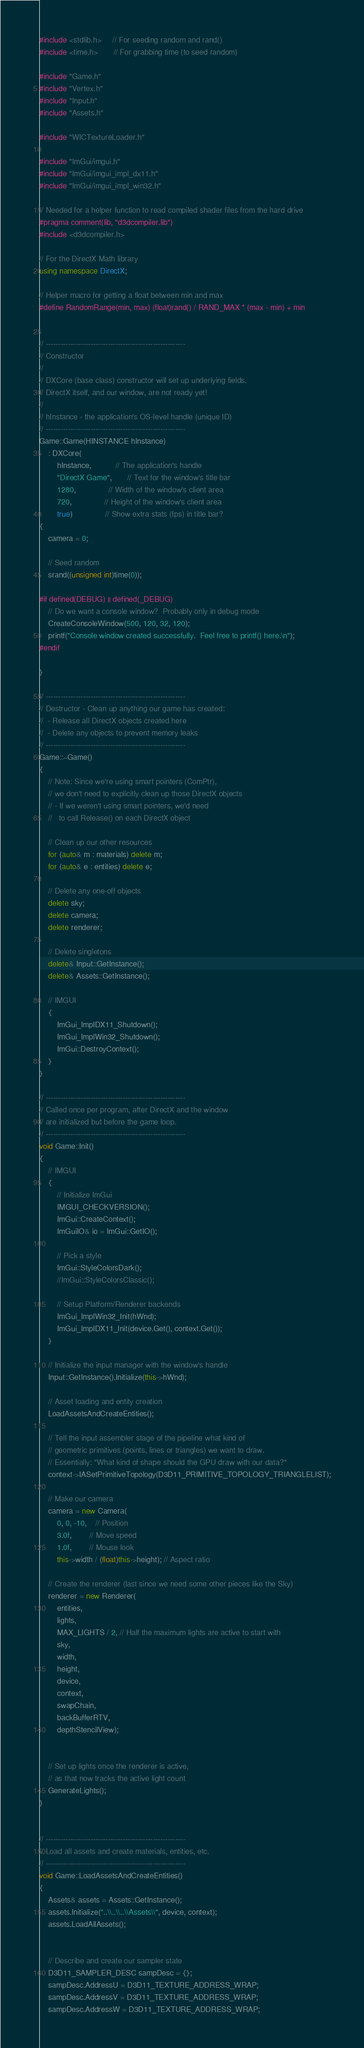Convert code to text. <code><loc_0><loc_0><loc_500><loc_500><_C++_>
#include <stdlib.h>     // For seeding random and rand()
#include <time.h>       // For grabbing time (to seed random)

#include "Game.h"
#include "Vertex.h"
#include "Input.h"
#include "Assets.h"

#include "WICTextureLoader.h"

#include "ImGui/imgui.h"
#include "ImGui/imgui_impl_dx11.h"
#include "ImGui/imgui_impl_win32.h"

// Needed for a helper function to read compiled shader files from the hard drive
#pragma comment(lib, "d3dcompiler.lib")
#include <d3dcompiler.h>

// For the DirectX Math library
using namespace DirectX;

// Helper macro for getting a float between min and max
#define RandomRange(min, max) (float)rand() / RAND_MAX * (max - min) + min


// --------------------------------------------------------
// Constructor
//
// DXCore (base class) constructor will set up underlying fields.
// DirectX itself, and our window, are not ready yet!
//
// hInstance - the application's OS-level handle (unique ID)
// --------------------------------------------------------
Game::Game(HINSTANCE hInstance)
	: DXCore(
		hInstance,		   // The application's handle
		"DirectX Game",	   // Text for the window's title bar
		1280,			   // Width of the window's client area
		720,			   // Height of the window's client area
		true)			   // Show extra stats (fps) in title bar?
{
	camera = 0;

	// Seed random
	srand((unsigned int)time(0));

#if defined(DEBUG) || defined(_DEBUG)
	// Do we want a console window?  Probably only in debug mode
	CreateConsoleWindow(500, 120, 32, 120);
	printf("Console window created successfully.  Feel free to printf() here.\n");
#endif

}

// --------------------------------------------------------
// Destructor - Clean up anything our game has created:
//  - Release all DirectX objects created here
//  - Delete any objects to prevent memory leaks
// --------------------------------------------------------
Game::~Game()
{
	// Note: Since we're using smart pointers (ComPtr),
	// we don't need to explicitly clean up those DirectX objects
	// - If we weren't using smart pointers, we'd need
	//   to call Release() on each DirectX object

	// Clean up our other resources
	for (auto& m : materials) delete m;
	for (auto& e : entities) delete e;

	// Delete any one-off objects
	delete sky;
	delete camera;
	delete renderer;

	// Delete singletons
	delete& Input::GetInstance();
	delete& Assets::GetInstance();

	// IMGUI
	{
		ImGui_ImplDX11_Shutdown();
		ImGui_ImplWin32_Shutdown();
		ImGui::DestroyContext();
	}
}

// --------------------------------------------------------
// Called once per program, after DirectX and the window
// are initialized but before the game loop.
// --------------------------------------------------------
void Game::Init()
{
	// IMGUI
	{
		// Initialize ImGui
		IMGUI_CHECKVERSION();
		ImGui::CreateContext();
		ImGuiIO& io = ImGui::GetIO();

		// Pick a style
		ImGui::StyleColorsDark();
		//ImGui::StyleColorsClassic();

		// Setup Platform/Renderer backends
		ImGui_ImplWin32_Init(hWnd);
		ImGui_ImplDX11_Init(device.Get(), context.Get());
	}

	// Initialize the input manager with the window's handle
	Input::GetInstance().Initialize(this->hWnd);

	// Asset loading and entity creation
	LoadAssetsAndCreateEntities();

	// Tell the input assembler stage of the pipeline what kind of
	// geometric primitives (points, lines or triangles) we want to draw.  
	// Essentially: "What kind of shape should the GPU draw with our data?"
	context->IASetPrimitiveTopology(D3D11_PRIMITIVE_TOPOLOGY_TRIANGLELIST);

	// Make our camera
	camera = new Camera(
		0, 0, -10,	// Position
		3.0f,		// Move speed
		1.0f,		// Mouse look
		this->width / (float)this->height); // Aspect ratio

	// Create the renderer (last since we need some other pieces like the Sky)
	renderer = new Renderer(
		entities,
		lights,
		MAX_LIGHTS / 2, // Half the maximum lights are active to start with
		sky,
		width,
		height,
		device,
		context,
		swapChain,
		backBufferRTV,
		depthStencilView);


	// Set up lights once the renderer is active,
	// as that now tracks the active light count
	GenerateLights();
}


// --------------------------------------------------------
// Load all assets and create materials, entities, etc.
// --------------------------------------------------------
void Game::LoadAssetsAndCreateEntities()
{
	Assets& assets = Assets::GetInstance();
	assets.Initialize("..\\..\\..\\Assets\\", device, context);
	assets.LoadAllAssets();


	// Describe and create our sampler state
	D3D11_SAMPLER_DESC sampDesc = {};
	sampDesc.AddressU = D3D11_TEXTURE_ADDRESS_WRAP;
	sampDesc.AddressV = D3D11_TEXTURE_ADDRESS_WRAP;
	sampDesc.AddressW = D3D11_TEXTURE_ADDRESS_WRAP;</code> 